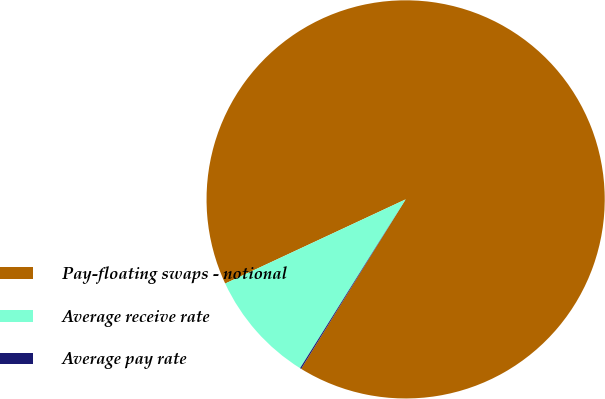Convert chart to OTSL. <chart><loc_0><loc_0><loc_500><loc_500><pie_chart><fcel>Pay-floating swaps - notional<fcel>Average receive rate<fcel>Average pay rate<nl><fcel>90.74%<fcel>9.16%<fcel>0.1%<nl></chart> 